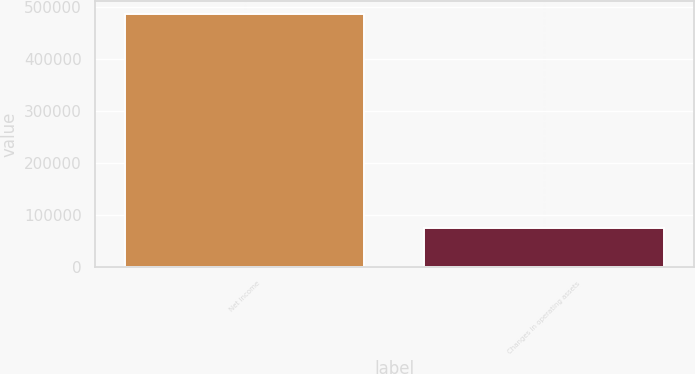<chart> <loc_0><loc_0><loc_500><loc_500><bar_chart><fcel>Net income<fcel>Changes in operating assets<nl><fcel>487077<fcel>75180<nl></chart> 